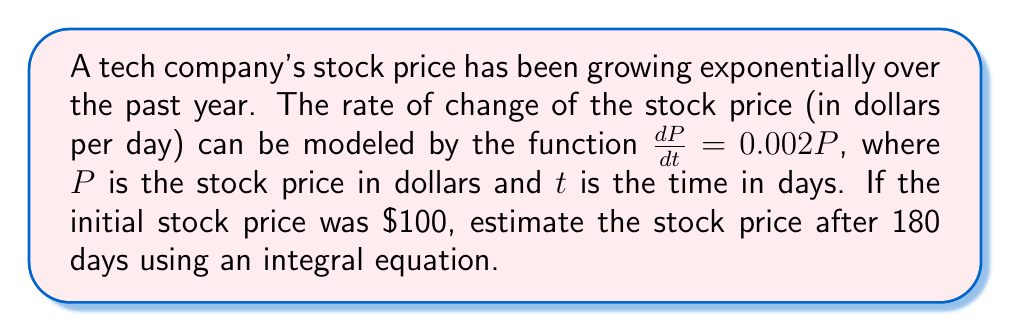Help me with this question. Let's approach this step-by-step:

1) We're given the rate of change equation: $\frac{dP}{dt} = 0.002P$

2) To find the stock price after 180 days, we need to integrate this equation:

   $\int \frac{dP}{P} = \int 0.002 dt$

3) Integrating both sides:

   $\ln|P| = 0.002t + C$, where C is the constant of integration

4) We can rewrite this as:

   $P = e^{0.002t + C} = e^C \cdot e^{0.002t}$

5) To find $e^C$, we use the initial condition: when $t=0$, $P=100$

   $100 = e^C \cdot e^{0.002 \cdot 0} = e^C$

6) So our final equation is:

   $P = 100 \cdot e^{0.002t}$

7) To find the price after 180 days, we plug in $t=180$:

   $P = 100 \cdot e^{0.002 \cdot 180} = 100 \cdot e^{0.36} \approx 143.33$

Therefore, after 180 days, the estimated stock price will be approximately $143.33.
Answer: $143.33 